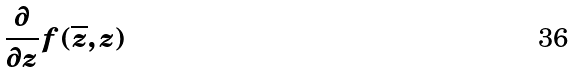<formula> <loc_0><loc_0><loc_500><loc_500>\frac { \partial } { \partial z } f ( \overline { z } , z )</formula> 